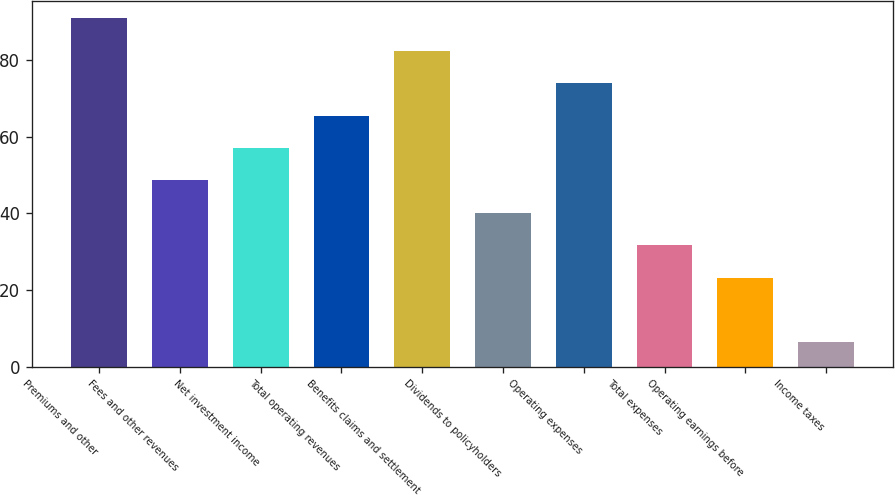Convert chart to OTSL. <chart><loc_0><loc_0><loc_500><loc_500><bar_chart><fcel>Premiums and other<fcel>Fees and other revenues<fcel>Net investment income<fcel>Total operating revenues<fcel>Benefits claims and settlement<fcel>Dividends to policyholders<fcel>Operating expenses<fcel>Total expenses<fcel>Operating earnings before<fcel>Income taxes<nl><fcel>90.9<fcel>48.6<fcel>57.06<fcel>65.52<fcel>82.44<fcel>40.14<fcel>73.98<fcel>31.68<fcel>23.22<fcel>6.3<nl></chart> 